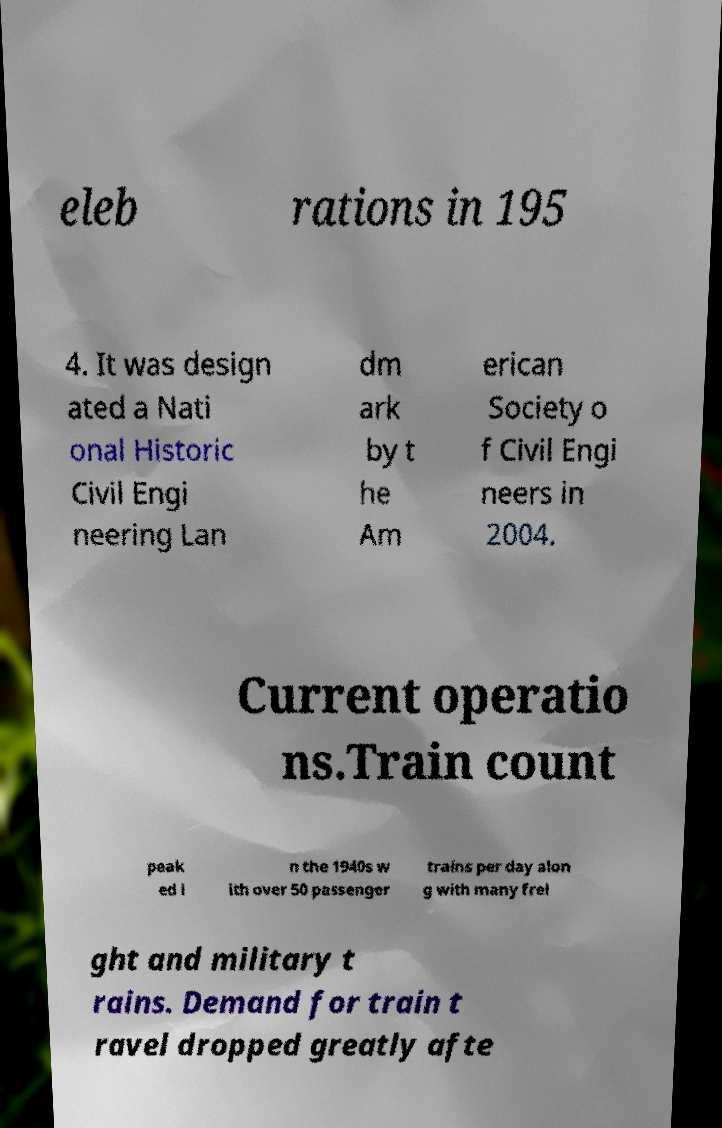There's text embedded in this image that I need extracted. Can you transcribe it verbatim? eleb rations in 195 4. It was design ated a Nati onal Historic Civil Engi neering Lan dm ark by t he Am erican Society o f Civil Engi neers in 2004. Current operatio ns.Train count peak ed i n the 1940s w ith over 50 passenger trains per day alon g with many frei ght and military t rains. Demand for train t ravel dropped greatly afte 